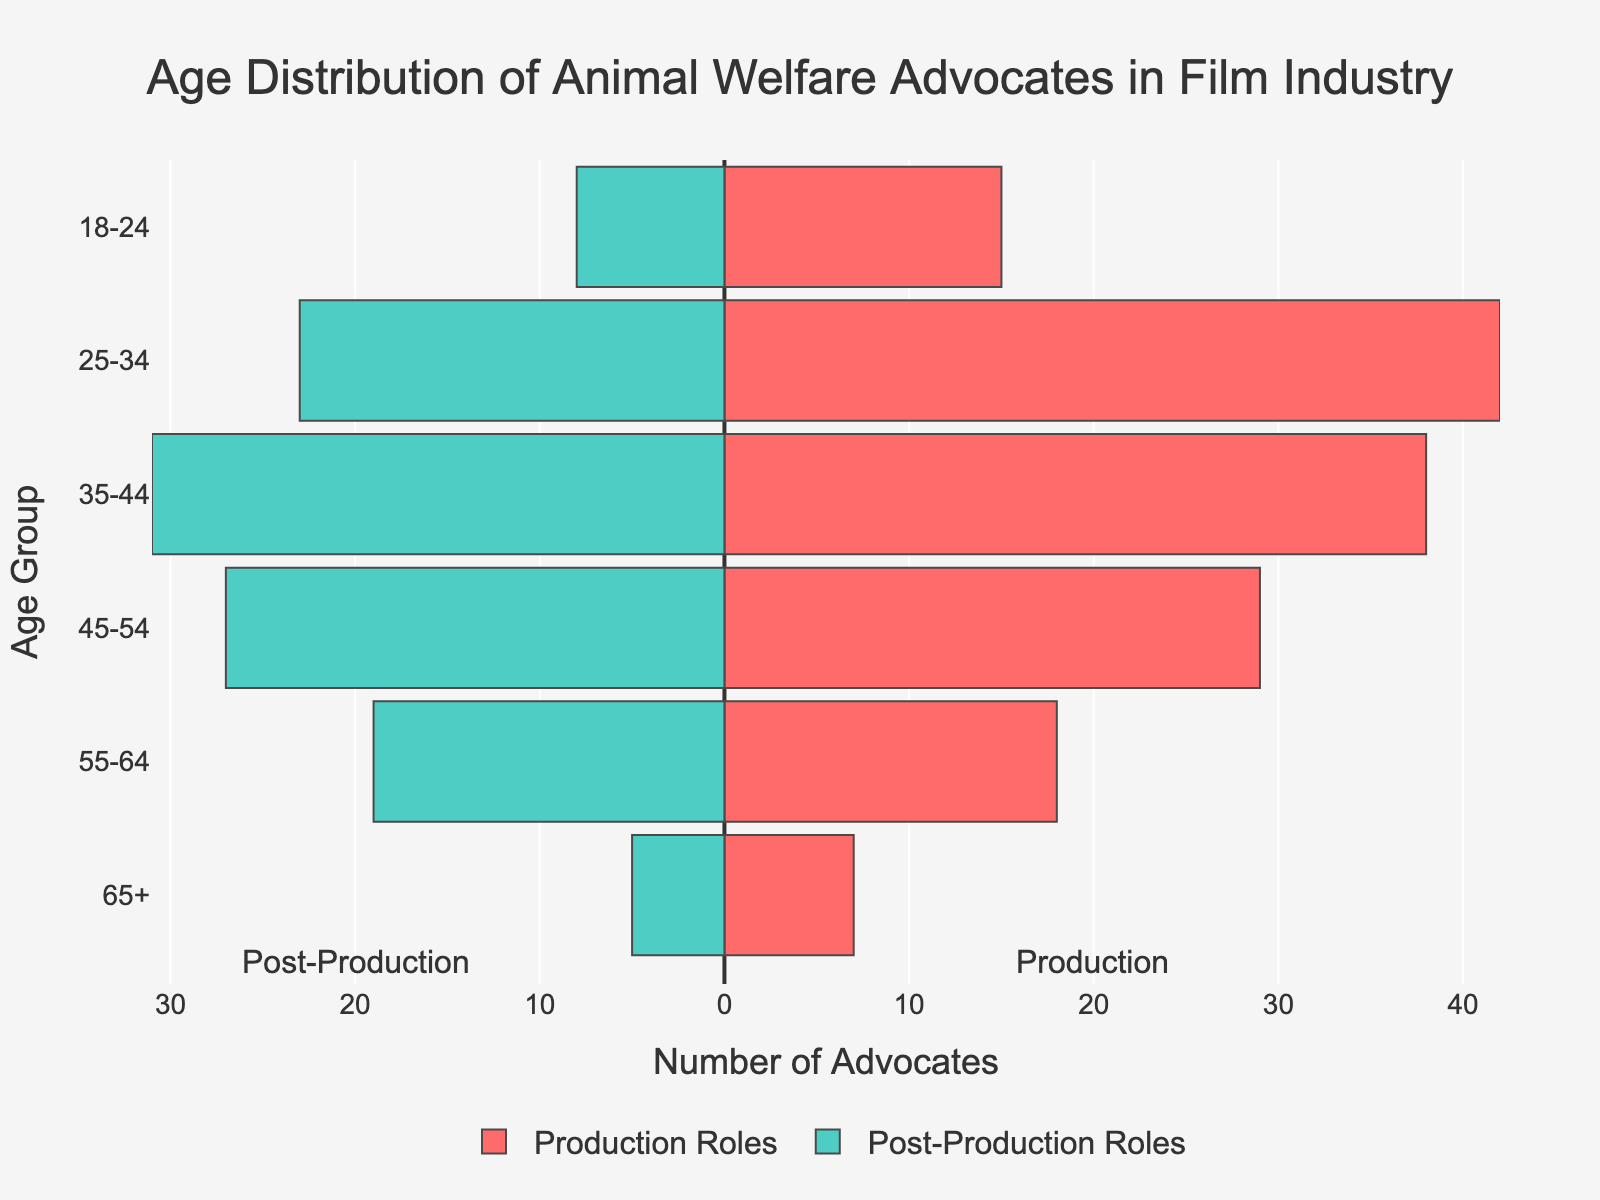What age group has the highest number of advocates in production roles? The figure shows that the 25-34 age group in production roles has the highest bar length, indicating the highest number of advocates.
Answer: 25-34 Which group has more advocates in the 45-54 age range, production or post-production roles? By comparing the bars for the 45-54 age group, the production roles bar is longer than the post-production roles bar.
Answer: Production roles What's the total number of advocates in the 18-24 age group for both production and post-production roles combined? Add the numbers for the 18-24 age group from both roles: 15 (production) + 8 (post-production) = 23
Answer: 23 Compare the number of advocates in the 55-64 age group with those in the 65+ age group for production roles. Which group is larger and by how much? The figure shows 18 advocates in the 55-64 age group and 7 in the 65+ age group for production roles. Subtract the two: 18 - 7 = 11.
Answer: 55-64 by 11 Which age group has the lowest number of advocates in post-production roles? The shortest bar on the left side for post-production roles belongs to the 65+ age group.
Answer: 65+ How does the number of advocates in the 35-44 age group for production roles compare to those in post-production roles? Compare the bars for the 35-44 age group: 38 (production) and 31 (post-production). The production number is 7 more than the post-production number.
Answer: Production by 7 What's the difference in the number of advocates between the 25-34 and 35-44 age groups in production roles? Subtract the numbers: 42 (25-34) - 38 (35-44) = 4
Answer: 4 How many total advocates are there in the 65+ age group across both roles? Add the advocates from both roles in the 65+ age group: 7 (production) + 5 (post-production) = 12
Answer: 12 Describe the trend in the number of advocates across age groups in production roles. The number increases from 18-24 to 25-34, then gradually decreases with each successive age group.
Answer: Increase then decrease What's the color representation for production and post-production roles in the figure? Production roles are represented in red, while post-production roles are in teal.
Answer: Red and teal 